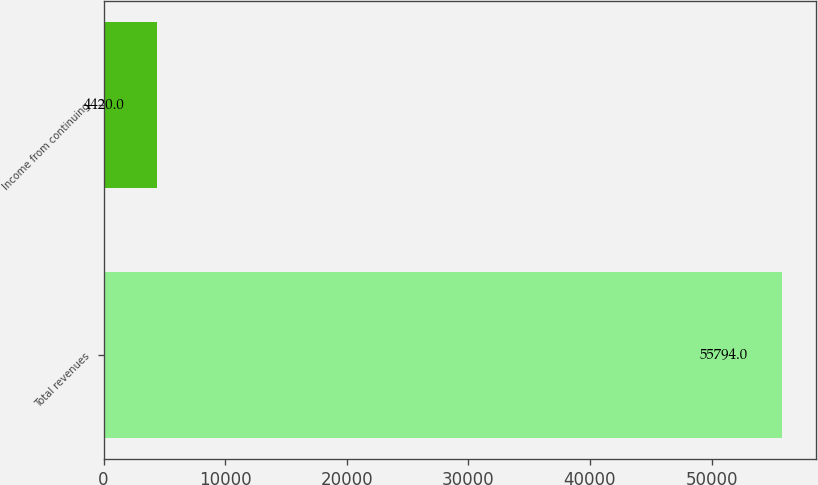<chart> <loc_0><loc_0><loc_500><loc_500><bar_chart><fcel>Total revenues<fcel>Income from continuing<nl><fcel>55794<fcel>4420<nl></chart> 